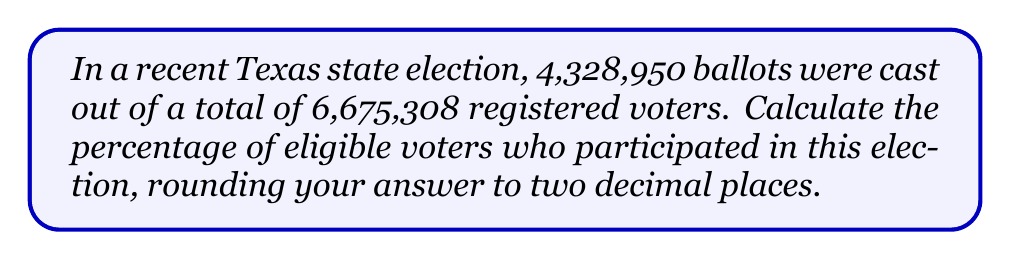Solve this math problem. To calculate the percentage of eligible voters who participated in the election, we need to follow these steps:

1. Identify the number of ballots cast (voters who participated):
   $n_{participants} = 4,328,950$

2. Identify the total number of registered voters (eligible voters):
   $n_{total} = 6,675,308$

3. Calculate the ratio of participants to total eligible voters:
   $$\text{ratio} = \frac{n_{participants}}{n_{total}} = \frac{4,328,950}{6,675,308}$$

4. Convert the ratio to a percentage by multiplying by 100:
   $$\text{percentage} = \text{ratio} \times 100 = \frac{4,328,950}{6,675,308} \times 100$$

5. Perform the calculation:
   $$\text{percentage} = 0.6485178... \times 100 = 64.85178...$$

6. Round the result to two decimal places:
   $$\text{percentage} \approx 64.85\%$$

Therefore, the percentage of eligible voters who participated in the recent Texas state election is approximately 64.85%.
Answer: 64.85% 